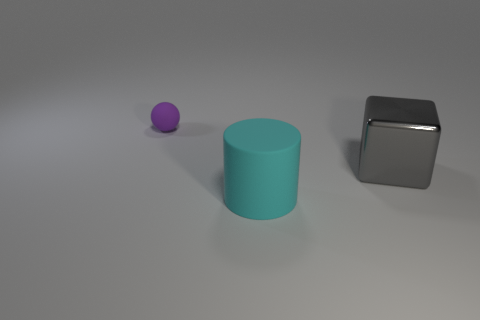Add 3 yellow balls. How many objects exist? 6 Subtract all cubes. How many objects are left? 2 Add 1 shiny cubes. How many shiny cubes are left? 2 Add 3 tiny brown things. How many tiny brown things exist? 3 Subtract 1 cyan cylinders. How many objects are left? 2 Subtract all large metallic blocks. Subtract all large yellow rubber cylinders. How many objects are left? 2 